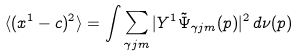<formula> <loc_0><loc_0><loc_500><loc_500>\langle ( x ^ { 1 } - c ) ^ { 2 } \rangle = \int \sum _ { \gamma j m } | Y ^ { 1 } \tilde { \Psi } _ { \gamma j m } ( p ) | ^ { 2 } \, d \nu ( p )</formula> 